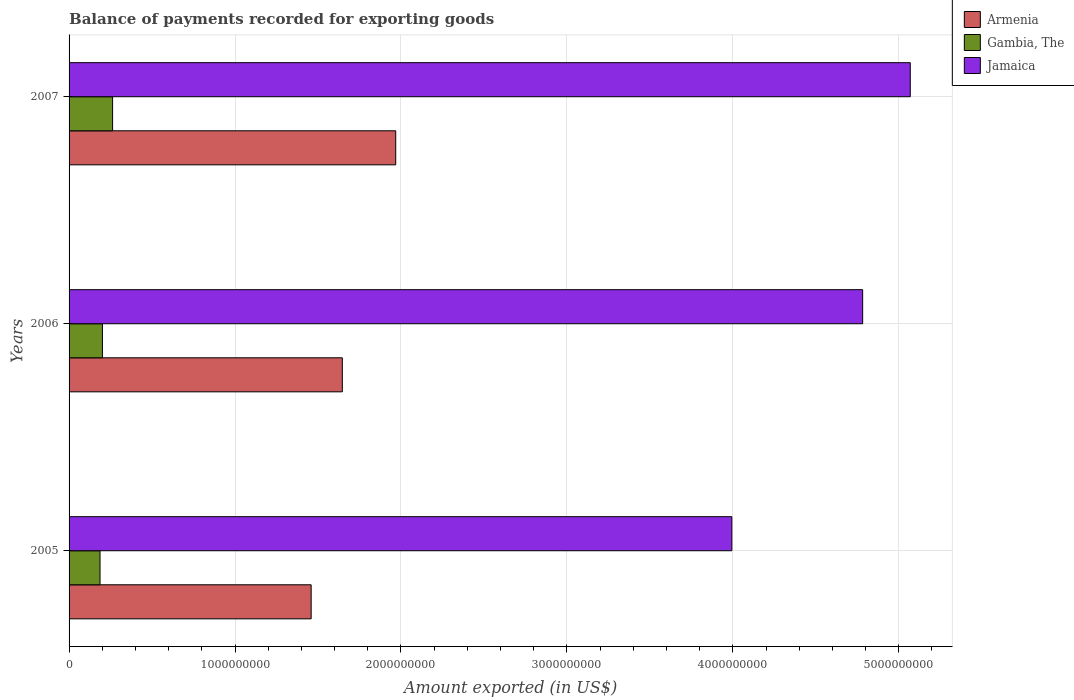Are the number of bars on each tick of the Y-axis equal?
Your answer should be very brief. Yes. How many bars are there on the 1st tick from the top?
Ensure brevity in your answer.  3. What is the amount exported in Gambia, The in 2005?
Keep it short and to the point. 1.87e+08. Across all years, what is the maximum amount exported in Gambia, The?
Ensure brevity in your answer.  2.62e+08. Across all years, what is the minimum amount exported in Jamaica?
Your answer should be very brief. 3.99e+09. In which year was the amount exported in Gambia, The minimum?
Your answer should be compact. 2005. What is the total amount exported in Armenia in the graph?
Your response must be concise. 5.07e+09. What is the difference between the amount exported in Jamaica in 2005 and that in 2007?
Give a very brief answer. -1.08e+09. What is the difference between the amount exported in Jamaica in 2006 and the amount exported in Gambia, The in 2005?
Your response must be concise. 4.60e+09. What is the average amount exported in Jamaica per year?
Your response must be concise. 4.62e+09. In the year 2007, what is the difference between the amount exported in Jamaica and amount exported in Gambia, The?
Ensure brevity in your answer.  4.81e+09. What is the ratio of the amount exported in Gambia, The in 2006 to that in 2007?
Make the answer very short. 0.77. Is the difference between the amount exported in Jamaica in 2005 and 2006 greater than the difference between the amount exported in Gambia, The in 2005 and 2006?
Keep it short and to the point. No. What is the difference between the highest and the second highest amount exported in Armenia?
Your response must be concise. 3.22e+08. What is the difference between the highest and the lowest amount exported in Jamaica?
Your answer should be very brief. 1.08e+09. In how many years, is the amount exported in Armenia greater than the average amount exported in Armenia taken over all years?
Provide a short and direct response. 1. Is the sum of the amount exported in Gambia, The in 2005 and 2007 greater than the maximum amount exported in Armenia across all years?
Ensure brevity in your answer.  No. What does the 3rd bar from the top in 2006 represents?
Your answer should be compact. Armenia. What does the 2nd bar from the bottom in 2005 represents?
Your answer should be compact. Gambia, The. Are all the bars in the graph horizontal?
Give a very brief answer. Yes. How many years are there in the graph?
Provide a succinct answer. 3. Are the values on the major ticks of X-axis written in scientific E-notation?
Your answer should be very brief. No. Does the graph contain grids?
Ensure brevity in your answer.  Yes. Where does the legend appear in the graph?
Offer a terse response. Top right. How many legend labels are there?
Keep it short and to the point. 3. How are the legend labels stacked?
Ensure brevity in your answer.  Vertical. What is the title of the graph?
Your answer should be very brief. Balance of payments recorded for exporting goods. What is the label or title of the X-axis?
Provide a short and direct response. Amount exported (in US$). What is the label or title of the Y-axis?
Make the answer very short. Years. What is the Amount exported (in US$) in Armenia in 2005?
Make the answer very short. 1.46e+09. What is the Amount exported (in US$) in Gambia, The in 2005?
Offer a terse response. 1.87e+08. What is the Amount exported (in US$) of Jamaica in 2005?
Offer a terse response. 3.99e+09. What is the Amount exported (in US$) of Armenia in 2006?
Give a very brief answer. 1.65e+09. What is the Amount exported (in US$) of Gambia, The in 2006?
Give a very brief answer. 2.01e+08. What is the Amount exported (in US$) in Jamaica in 2006?
Offer a terse response. 4.78e+09. What is the Amount exported (in US$) in Armenia in 2007?
Make the answer very short. 1.97e+09. What is the Amount exported (in US$) in Gambia, The in 2007?
Offer a terse response. 2.62e+08. What is the Amount exported (in US$) in Jamaica in 2007?
Keep it short and to the point. 5.07e+09. Across all years, what is the maximum Amount exported (in US$) in Armenia?
Your response must be concise. 1.97e+09. Across all years, what is the maximum Amount exported (in US$) of Gambia, The?
Your response must be concise. 2.62e+08. Across all years, what is the maximum Amount exported (in US$) in Jamaica?
Keep it short and to the point. 5.07e+09. Across all years, what is the minimum Amount exported (in US$) in Armenia?
Ensure brevity in your answer.  1.46e+09. Across all years, what is the minimum Amount exported (in US$) of Gambia, The?
Offer a very short reply. 1.87e+08. Across all years, what is the minimum Amount exported (in US$) of Jamaica?
Your answer should be compact. 3.99e+09. What is the total Amount exported (in US$) in Armenia in the graph?
Provide a short and direct response. 5.07e+09. What is the total Amount exported (in US$) of Gambia, The in the graph?
Your answer should be very brief. 6.50e+08. What is the total Amount exported (in US$) in Jamaica in the graph?
Give a very brief answer. 1.38e+1. What is the difference between the Amount exported (in US$) in Armenia in 2005 and that in 2006?
Keep it short and to the point. -1.88e+08. What is the difference between the Amount exported (in US$) in Gambia, The in 2005 and that in 2006?
Make the answer very short. -1.44e+07. What is the difference between the Amount exported (in US$) of Jamaica in 2005 and that in 2006?
Provide a short and direct response. -7.88e+08. What is the difference between the Amount exported (in US$) in Armenia in 2005 and that in 2007?
Your answer should be compact. -5.10e+08. What is the difference between the Amount exported (in US$) in Gambia, The in 2005 and that in 2007?
Offer a very short reply. -7.57e+07. What is the difference between the Amount exported (in US$) of Jamaica in 2005 and that in 2007?
Provide a succinct answer. -1.08e+09. What is the difference between the Amount exported (in US$) in Armenia in 2006 and that in 2007?
Your response must be concise. -3.22e+08. What is the difference between the Amount exported (in US$) of Gambia, The in 2006 and that in 2007?
Keep it short and to the point. -6.13e+07. What is the difference between the Amount exported (in US$) in Jamaica in 2006 and that in 2007?
Your response must be concise. -2.87e+08. What is the difference between the Amount exported (in US$) of Armenia in 2005 and the Amount exported (in US$) of Gambia, The in 2006?
Ensure brevity in your answer.  1.26e+09. What is the difference between the Amount exported (in US$) of Armenia in 2005 and the Amount exported (in US$) of Jamaica in 2006?
Offer a terse response. -3.32e+09. What is the difference between the Amount exported (in US$) in Gambia, The in 2005 and the Amount exported (in US$) in Jamaica in 2006?
Ensure brevity in your answer.  -4.60e+09. What is the difference between the Amount exported (in US$) of Armenia in 2005 and the Amount exported (in US$) of Gambia, The in 2007?
Provide a short and direct response. 1.20e+09. What is the difference between the Amount exported (in US$) in Armenia in 2005 and the Amount exported (in US$) in Jamaica in 2007?
Keep it short and to the point. -3.61e+09. What is the difference between the Amount exported (in US$) in Gambia, The in 2005 and the Amount exported (in US$) in Jamaica in 2007?
Provide a short and direct response. -4.88e+09. What is the difference between the Amount exported (in US$) in Armenia in 2006 and the Amount exported (in US$) in Gambia, The in 2007?
Your answer should be very brief. 1.38e+09. What is the difference between the Amount exported (in US$) in Armenia in 2006 and the Amount exported (in US$) in Jamaica in 2007?
Make the answer very short. -3.42e+09. What is the difference between the Amount exported (in US$) in Gambia, The in 2006 and the Amount exported (in US$) in Jamaica in 2007?
Offer a very short reply. -4.87e+09. What is the average Amount exported (in US$) of Armenia per year?
Your answer should be very brief. 1.69e+09. What is the average Amount exported (in US$) in Gambia, The per year?
Ensure brevity in your answer.  2.17e+08. What is the average Amount exported (in US$) of Jamaica per year?
Ensure brevity in your answer.  4.62e+09. In the year 2005, what is the difference between the Amount exported (in US$) of Armenia and Amount exported (in US$) of Gambia, The?
Make the answer very short. 1.27e+09. In the year 2005, what is the difference between the Amount exported (in US$) in Armenia and Amount exported (in US$) in Jamaica?
Provide a short and direct response. -2.54e+09. In the year 2005, what is the difference between the Amount exported (in US$) in Gambia, The and Amount exported (in US$) in Jamaica?
Make the answer very short. -3.81e+09. In the year 2006, what is the difference between the Amount exported (in US$) in Armenia and Amount exported (in US$) in Gambia, The?
Offer a terse response. 1.45e+09. In the year 2006, what is the difference between the Amount exported (in US$) of Armenia and Amount exported (in US$) of Jamaica?
Provide a succinct answer. -3.14e+09. In the year 2006, what is the difference between the Amount exported (in US$) in Gambia, The and Amount exported (in US$) in Jamaica?
Give a very brief answer. -4.58e+09. In the year 2007, what is the difference between the Amount exported (in US$) in Armenia and Amount exported (in US$) in Gambia, The?
Give a very brief answer. 1.71e+09. In the year 2007, what is the difference between the Amount exported (in US$) of Armenia and Amount exported (in US$) of Jamaica?
Keep it short and to the point. -3.10e+09. In the year 2007, what is the difference between the Amount exported (in US$) in Gambia, The and Amount exported (in US$) in Jamaica?
Your answer should be compact. -4.81e+09. What is the ratio of the Amount exported (in US$) of Armenia in 2005 to that in 2006?
Your answer should be compact. 0.89. What is the ratio of the Amount exported (in US$) in Gambia, The in 2005 to that in 2006?
Provide a short and direct response. 0.93. What is the ratio of the Amount exported (in US$) in Jamaica in 2005 to that in 2006?
Your answer should be compact. 0.84. What is the ratio of the Amount exported (in US$) of Armenia in 2005 to that in 2007?
Your answer should be compact. 0.74. What is the ratio of the Amount exported (in US$) of Gambia, The in 2005 to that in 2007?
Provide a short and direct response. 0.71. What is the ratio of the Amount exported (in US$) in Jamaica in 2005 to that in 2007?
Give a very brief answer. 0.79. What is the ratio of the Amount exported (in US$) of Armenia in 2006 to that in 2007?
Provide a succinct answer. 0.84. What is the ratio of the Amount exported (in US$) in Gambia, The in 2006 to that in 2007?
Offer a terse response. 0.77. What is the ratio of the Amount exported (in US$) in Jamaica in 2006 to that in 2007?
Your response must be concise. 0.94. What is the difference between the highest and the second highest Amount exported (in US$) of Armenia?
Offer a very short reply. 3.22e+08. What is the difference between the highest and the second highest Amount exported (in US$) in Gambia, The?
Provide a succinct answer. 6.13e+07. What is the difference between the highest and the second highest Amount exported (in US$) in Jamaica?
Keep it short and to the point. 2.87e+08. What is the difference between the highest and the lowest Amount exported (in US$) in Armenia?
Offer a very short reply. 5.10e+08. What is the difference between the highest and the lowest Amount exported (in US$) in Gambia, The?
Your answer should be very brief. 7.57e+07. What is the difference between the highest and the lowest Amount exported (in US$) in Jamaica?
Your answer should be compact. 1.08e+09. 